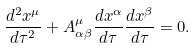Convert formula to latex. <formula><loc_0><loc_0><loc_500><loc_500>\frac { d ^ { 2 } x ^ { \mu } } { d \tau ^ { 2 } } + A ^ { \mu } _ { \alpha \beta } \frac { d x ^ { \alpha } } { d \tau } \frac { d x ^ { \beta } } { d \tau } = 0 .</formula> 